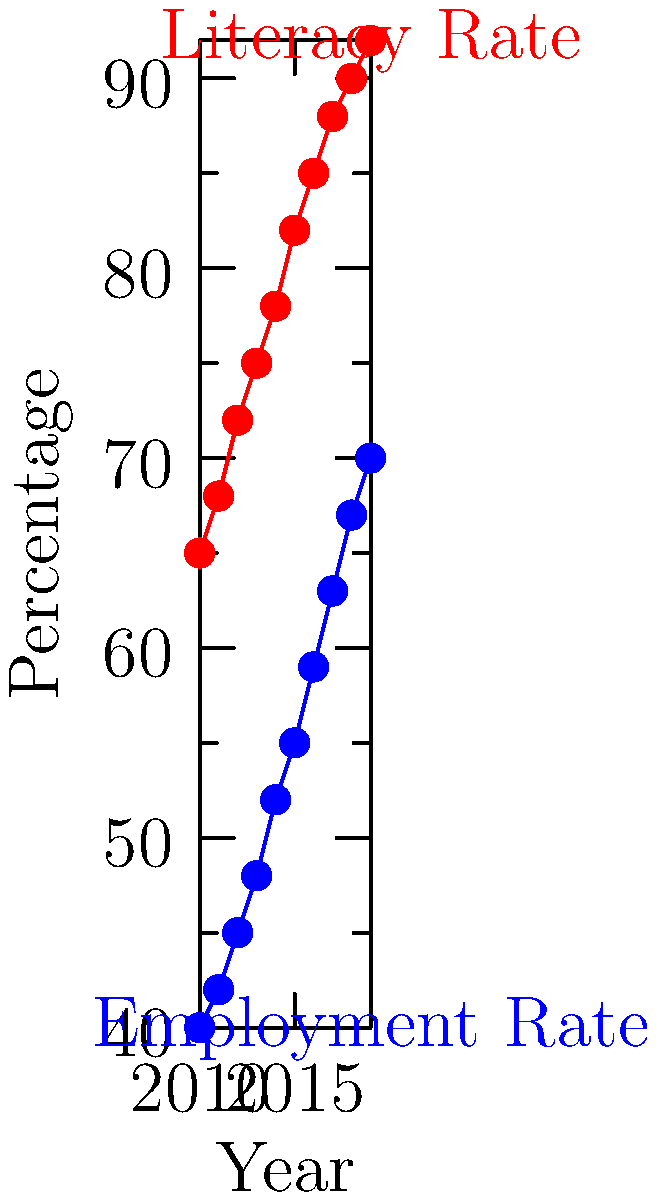Analyze the line graph depicting literacy and employment rates in a developing community from 2010 to 2019. What conclusion can be drawn about the relationship between education initiatives and community development based on this data? To analyze the impact of education initiatives on community development, we'll examine the trends in literacy and employment rates:

1. Literacy rate trend:
   - In 2010: 65%
   - In 2019: 92%
   - Increase: 27 percentage points

2. Employment rate trend:
   - In 2010: 40%
   - In 2019: 70%
   - Increase: 30 percentage points

3. Correlation analysis:
   - Both literacy and employment rates show consistent upward trends.
   - The increase in literacy rate (27 points) is similar to the increase in employment rate (30 points).
   - The slopes of both lines are relatively parallel, indicating a strong positive correlation.

4. Interpretation:
   - The rise in literacy rates suggests successful education initiatives.
   - The corresponding increase in employment rates indicates improved economic opportunities.
   - The parallel growth suggests that enhanced literacy skills likely contributed to better employment prospects.

5. Community development impact:
   - Higher literacy rates typically lead to a more skilled workforce.
   - Increased employment rates suggest economic growth and reduced poverty.
   - The combination of improved education and employment indicates overall community development.
Answer: The data shows a strong positive correlation between literacy and employment rates, suggesting that education initiatives have significantly contributed to community development by enhancing both human capital and economic opportunities. 